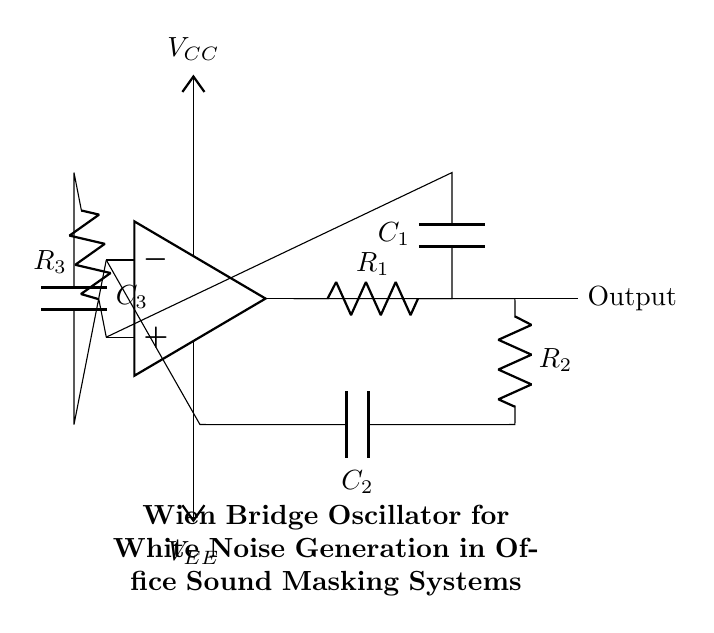What type of oscillator is depicted in the circuit? The circuit represents a Wien bridge oscillator, which is characterized by its specific feedback network structure intended for generating sine waves.
Answer: Wien bridge oscillator What are the components present in the feedback network? The feedback network consists of two resistors and two capacitors: R1, C1, R2, and C2. This arrangement helps to establish the frequency of oscillation.
Answer: R1, C1, R2, C2 What is the purpose of the output in this circuit? The output of the circuit is designed to produce a continuous waveform, specifically white noise, which can be used for sound masking in office environments.
Answer: Sound masking How does the Wien bridge oscillator stabilize its amplitude? The Wien bridge oscillator stabilizes its amplitude through a variable resistance or its feedback arrangement that automatically adjusts gain to keep oscillations stable without distortion.
Answer: Feedback adjustment What are the voltage supply levels indicated in the circuit? The circuit indicates a positive supply voltage of VCC and a negative supply voltage of VEE, which are necessary for the operation of the operational amplifier within the oscillator.
Answer: VCC and VEE 